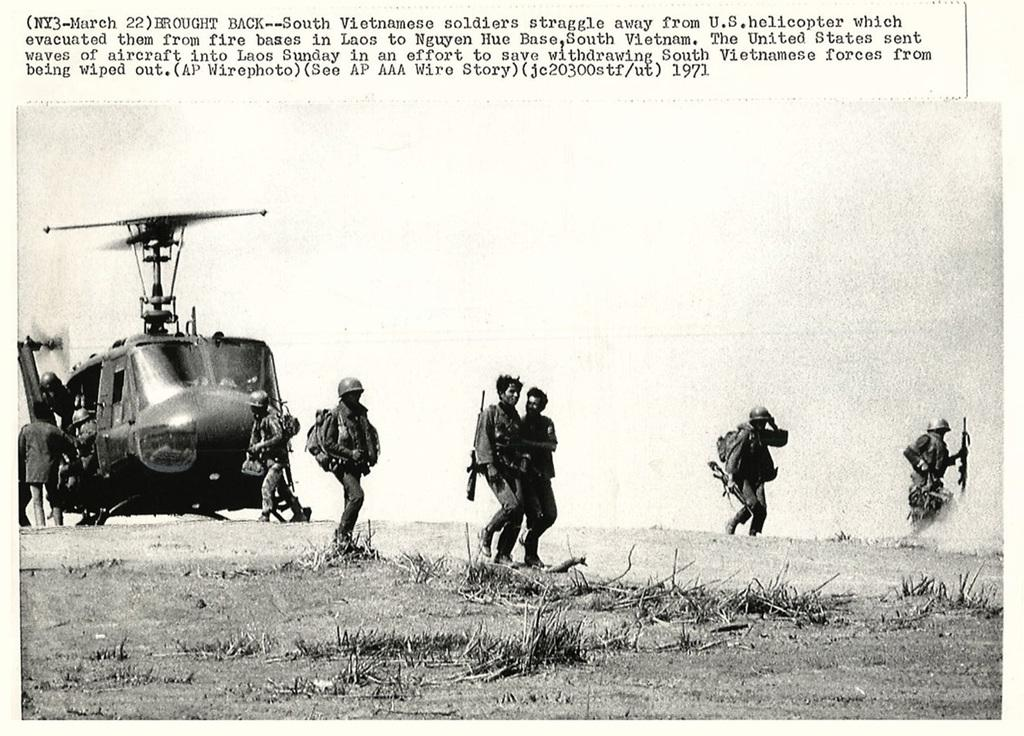What is the medium of the image? The image is on a paper. Who or what is depicted in the image? There are people and a helicopter in the image. What type of terrain is visible in the image? There is grass in the image. Is there any text present in the image? Yes, there is text written at the top of the picture. What type of animal can be seen performing magic tricks in the image? There is no animal or magic tricks present in the image; it features people, a helicopter, grass, and text. 